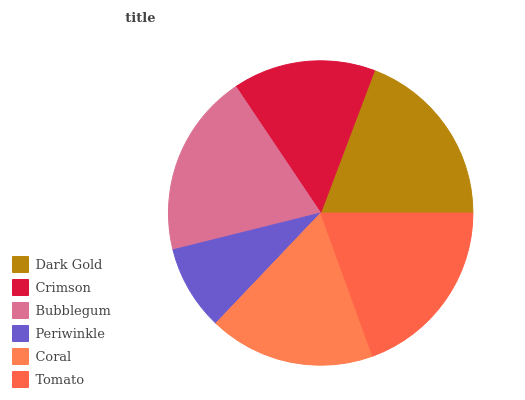Is Periwinkle the minimum?
Answer yes or no. Yes. Is Bubblegum the maximum?
Answer yes or no. Yes. Is Crimson the minimum?
Answer yes or no. No. Is Crimson the maximum?
Answer yes or no. No. Is Dark Gold greater than Crimson?
Answer yes or no. Yes. Is Crimson less than Dark Gold?
Answer yes or no. Yes. Is Crimson greater than Dark Gold?
Answer yes or no. No. Is Dark Gold less than Crimson?
Answer yes or no. No. Is Dark Gold the high median?
Answer yes or no. Yes. Is Coral the low median?
Answer yes or no. Yes. Is Crimson the high median?
Answer yes or no. No. Is Crimson the low median?
Answer yes or no. No. 